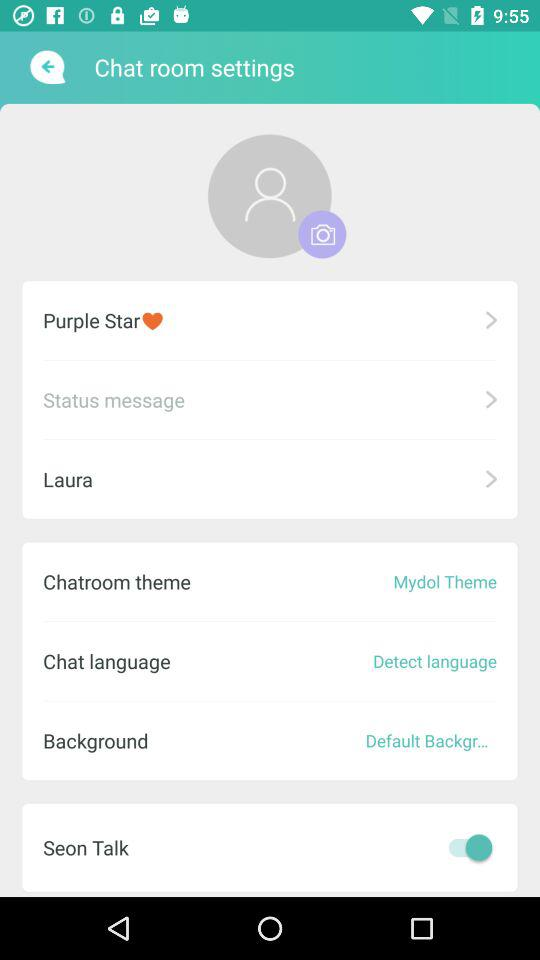What is the selected chatroom theme? The selected chatroom theme is "Mydol Theme". 